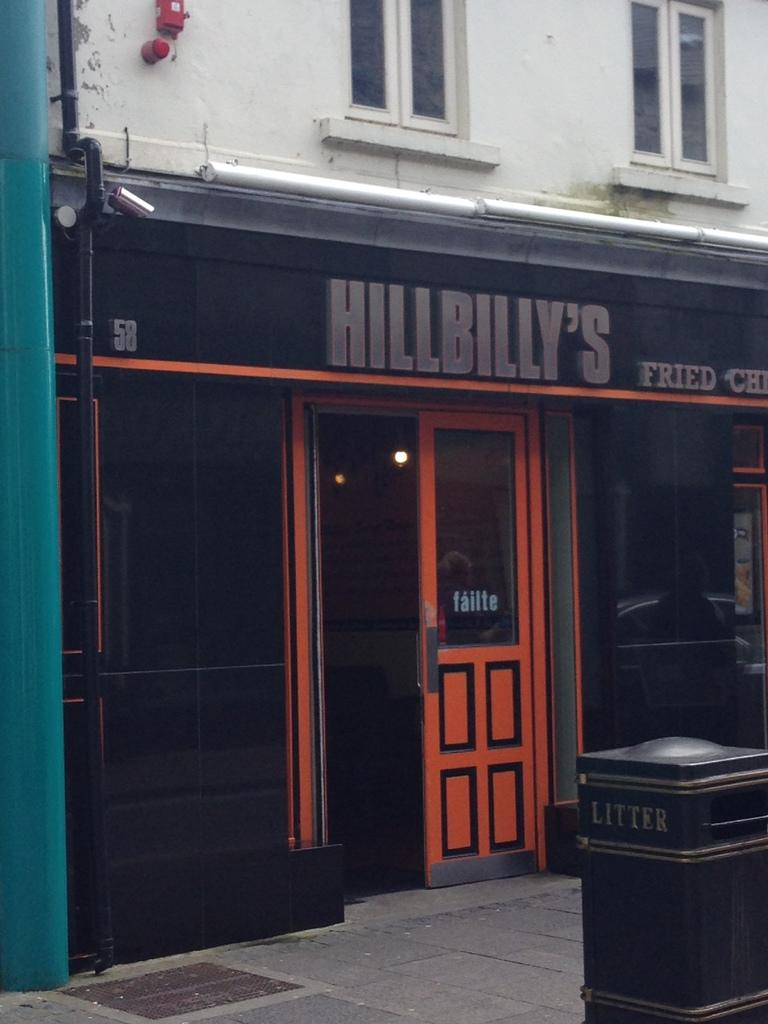What is located in the foreground area of the image? There is a door and text in the foreground area of the image. What can be found on the right side of the image? There is a trash bin on the bottom right side of the image. What is visible at the top side of the image? There are windows at the top side of the image. What objects are located on the left side of the image? There is a pole and a pipe on the left side of the image. What type of pain is being experienced by the bat in the image? There is no bat present in the image, and therefore no pain can be observed. Where is the pocket located in the image? There is no pocket present in the image. 